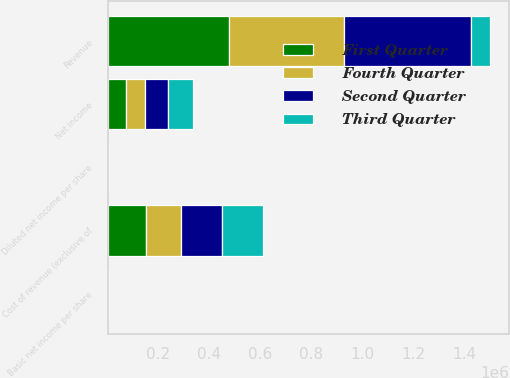<chart> <loc_0><loc_0><loc_500><loc_500><stacked_bar_chart><ecel><fcel>Revenue<fcel>Cost of revenue (exclusive of<fcel>Net income<fcel>Basic net income per share<fcel>Diluted net income per share<nl><fcel>Fourth Quarter<fcel>453502<fcel>139612<fcel>72800<fcel>0.41<fcel>0.4<nl><fcel>First Quarter<fcel>476035<fcel>149318<fcel>72886<fcel>0.41<fcel>0.4<nl><fcel>Second Quarter<fcel>498042<fcel>158812<fcel>91155<fcel>0.51<fcel>0.5<nl><fcel>Third Quarter<fcel>72886<fcel>163201<fcel>97107<fcel>0.55<fcel>0.54<nl></chart> 